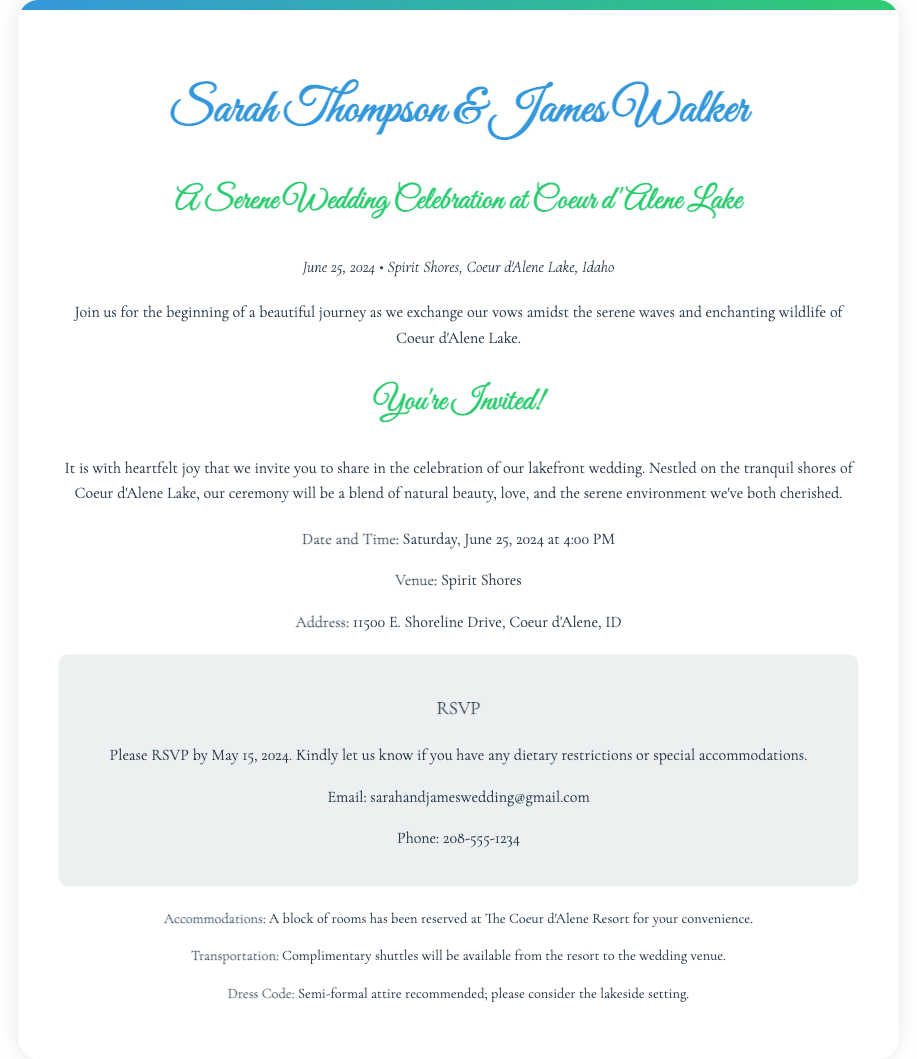What are the names of the couple? The names of the couple are stated at the top of the invitation.
Answer: Sarah Thompson & James Walker What is the date of the wedding? The date of the wedding is specified in the date-location section.
Answer: June 25, 2024 Where is the wedding venue? The venue is mentioned in the details section of the invitation.
Answer: Spirit Shores What time does the ceremony start? The start time is provided in the details section.
Answer: 4:00 PM What is the RSVP deadline? The RSVP deadline is clearly mentioned in the RSVP section.
Answer: May 15, 2024 What type of attire is recommended? The dress code is shared in the additional info section.
Answer: Semi-formal attire recommended How can guests RSVP? The RSVP method is provided in the RSVP section of the invitation.
Answer: Email or Phone What accommodations are available for guests? Accommodation details are found in the additional info section.
Answer: The Coeur d'Alene Resort Is transportation provided to the venue? The transportation information is indicated in the additional info section.
Answer: Complimentary shuttles available 